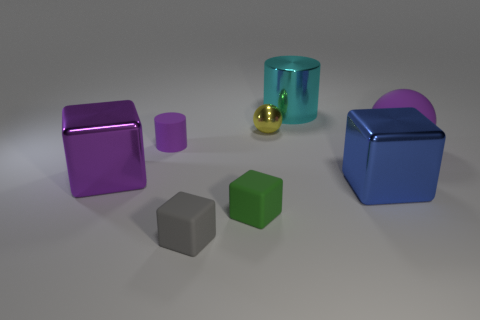Add 2 large cyan metallic cylinders. How many objects exist? 10 Subtract all cylinders. How many objects are left? 6 Subtract all cylinders. Subtract all blue cubes. How many objects are left? 5 Add 7 gray rubber objects. How many gray rubber objects are left? 8 Add 4 blocks. How many blocks exist? 8 Subtract 0 gray cylinders. How many objects are left? 8 